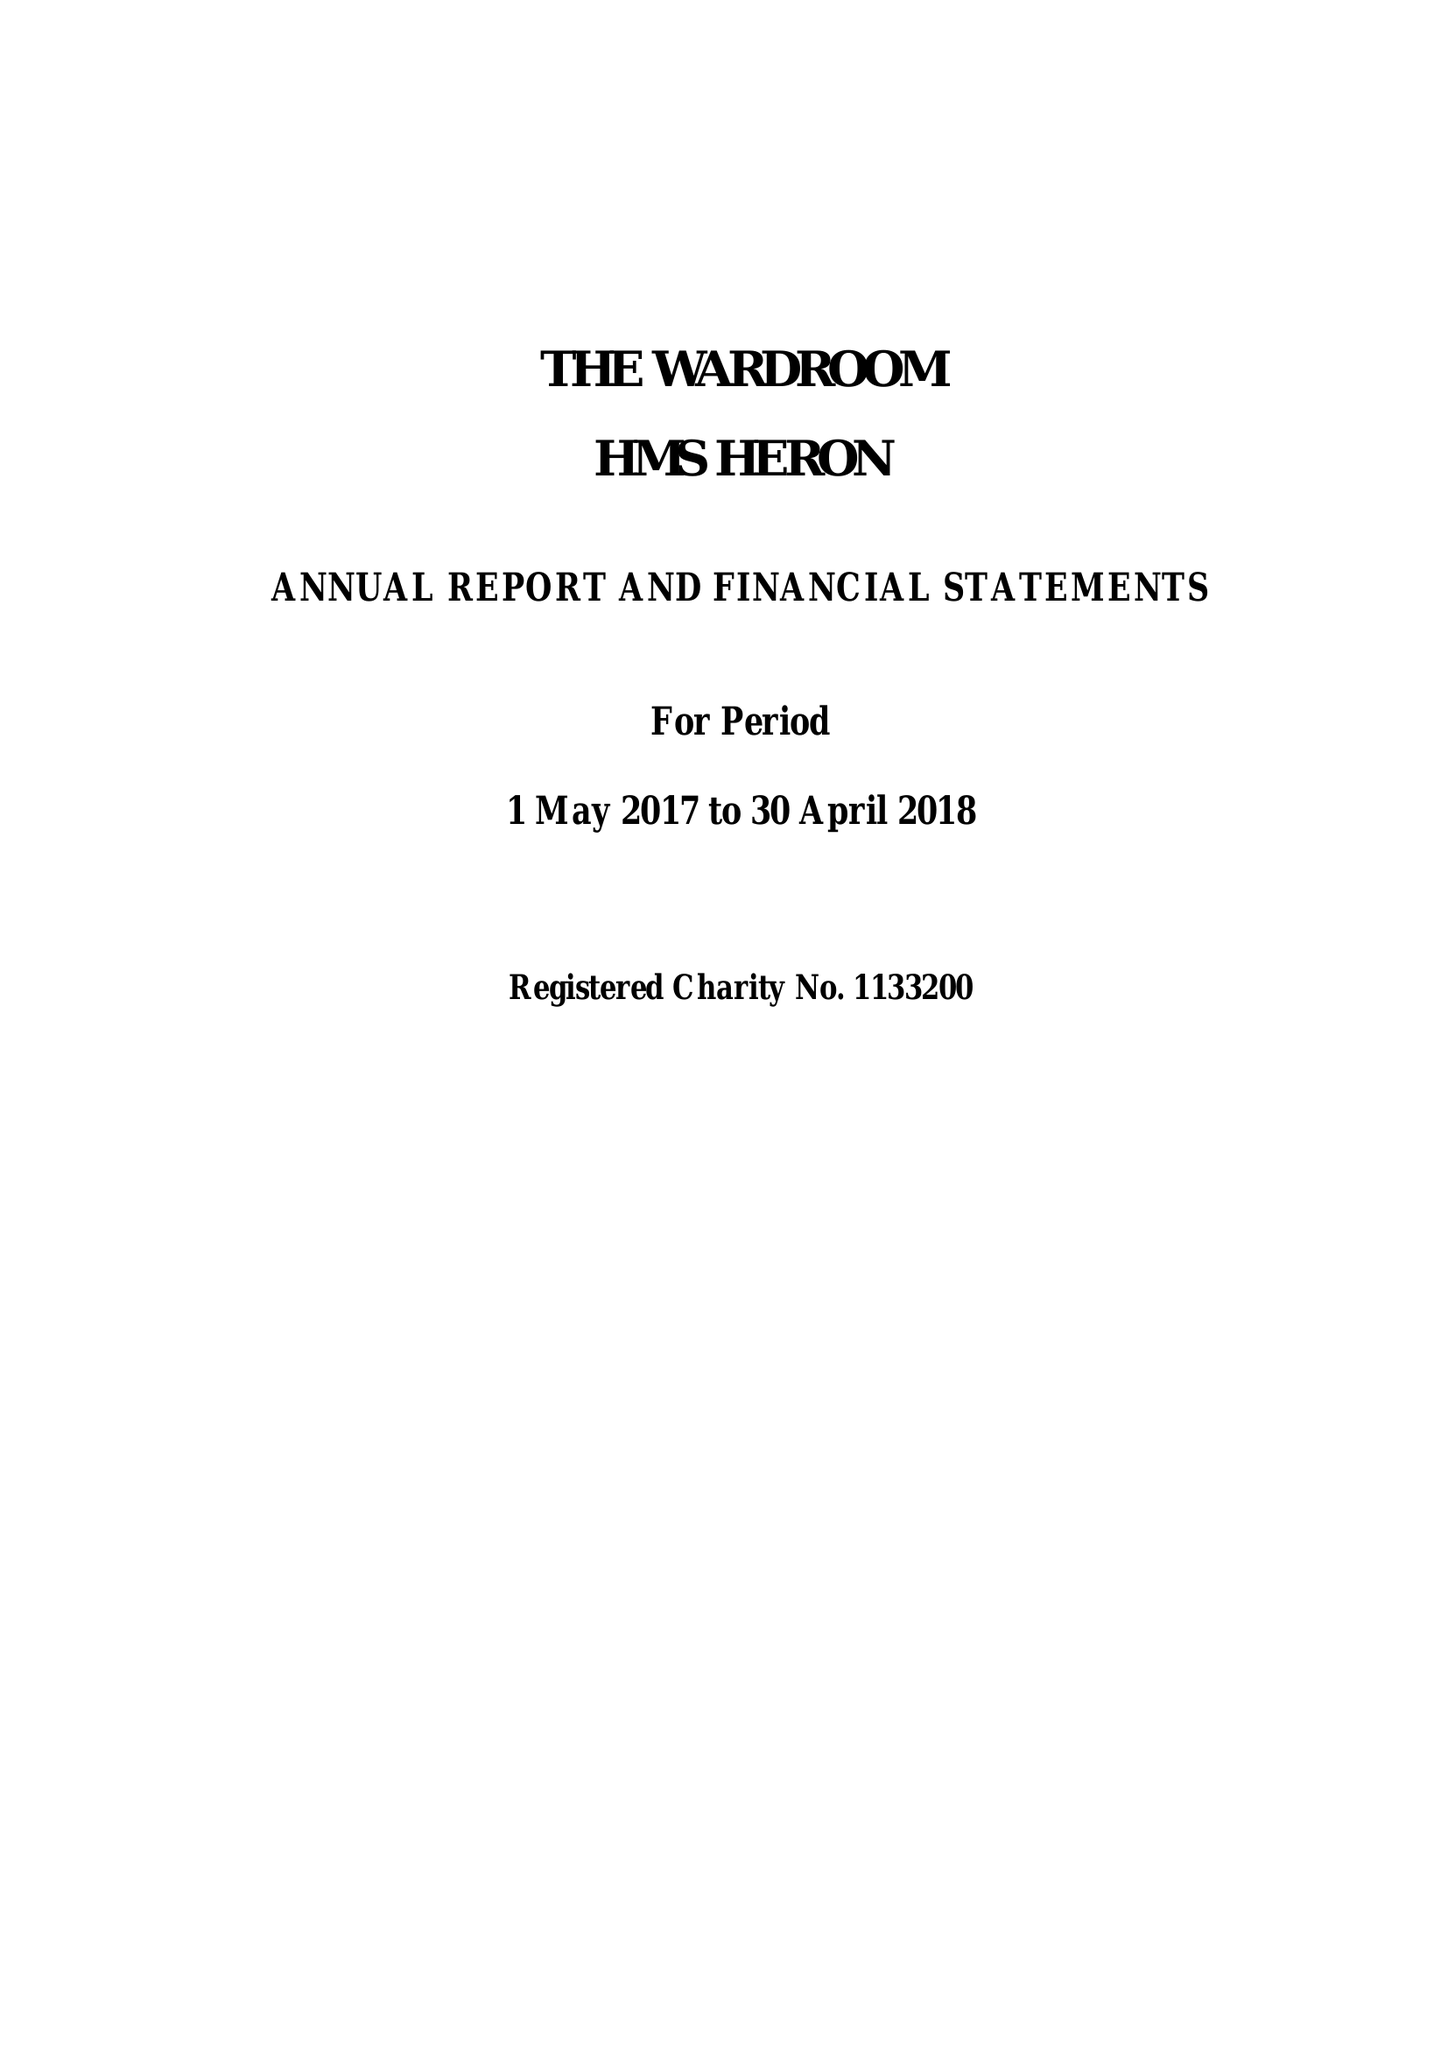What is the value for the charity_number?
Answer the question using a single word or phrase. 1133200 